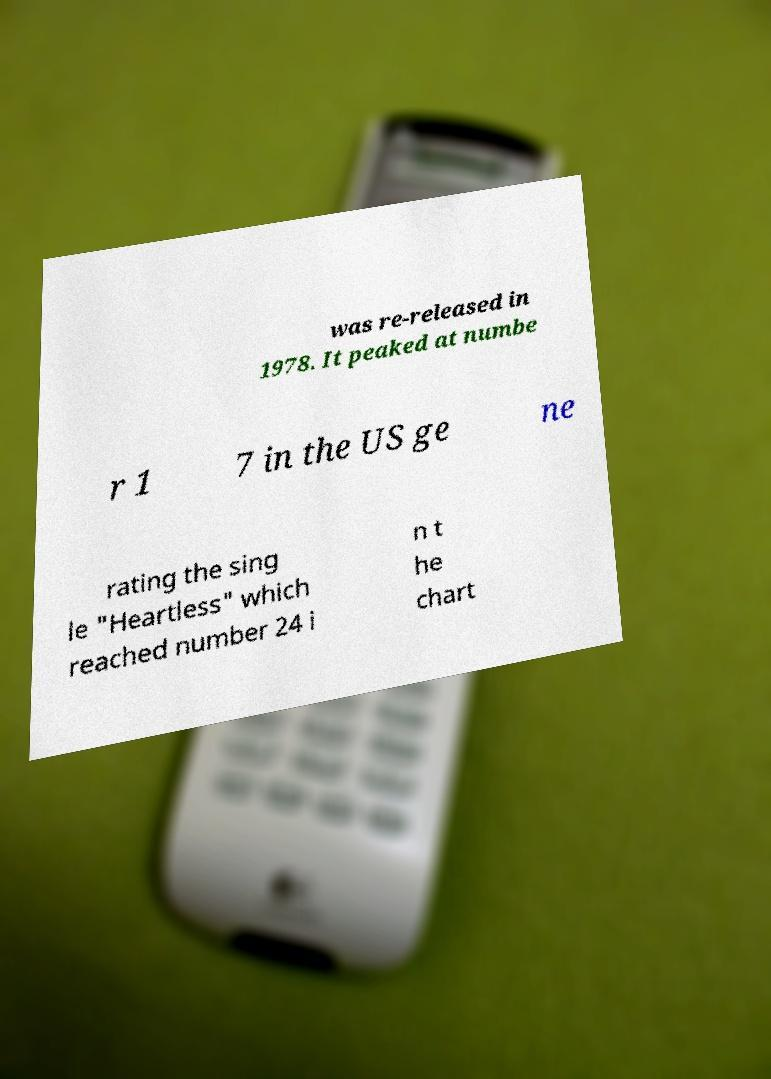What messages or text are displayed in this image? I need them in a readable, typed format. was re-released in 1978. It peaked at numbe r 1 7 in the US ge ne rating the sing le "Heartless" which reached number 24 i n t he chart 